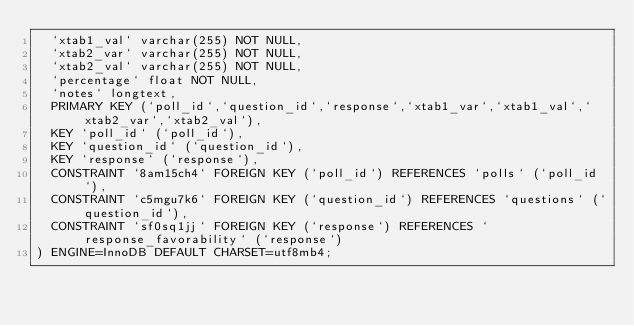Convert code to text. <code><loc_0><loc_0><loc_500><loc_500><_SQL_>  `xtab1_val` varchar(255) NOT NULL,
  `xtab2_var` varchar(255) NOT NULL,
  `xtab2_val` varchar(255) NOT NULL,
  `percentage` float NOT NULL,
  `notes` longtext,
  PRIMARY KEY (`poll_id`,`question_id`,`response`,`xtab1_var`,`xtab1_val`,`xtab2_var`,`xtab2_val`),
  KEY `poll_id` (`poll_id`),
  KEY `question_id` (`question_id`),
  KEY `response` (`response`),
  CONSTRAINT `8am15ch4` FOREIGN KEY (`poll_id`) REFERENCES `polls` (`poll_id`),
  CONSTRAINT `c5mgu7k6` FOREIGN KEY (`question_id`) REFERENCES `questions` (`question_id`),
  CONSTRAINT `sf0sq1jj` FOREIGN KEY (`response`) REFERENCES `response_favorability` (`response`)
) ENGINE=InnoDB DEFAULT CHARSET=utf8mb4;
</code> 